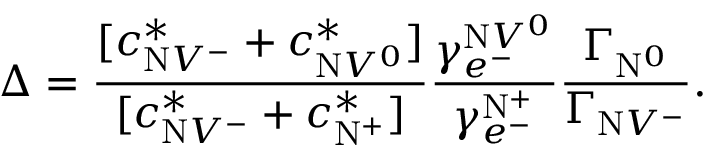Convert formula to latex. <formula><loc_0><loc_0><loc_500><loc_500>\Delta = \frac { [ c _ { N V ^ { - } } ^ { * } + c _ { N V ^ { 0 } } ^ { * } ] } { [ c _ { N V ^ { - } } ^ { * } + c _ { N ^ { + } } ^ { * } ] } \frac { \gamma _ { e ^ { - } } ^ { N V ^ { 0 } } } { \gamma _ { e ^ { - } } ^ { N ^ { + } } } \frac { \Gamma _ { N ^ { 0 } } } { \Gamma _ { N V ^ { - } } } .</formula> 